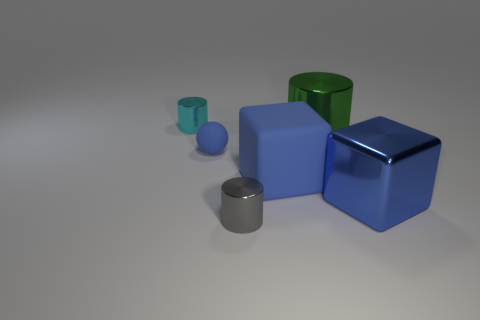There is a cyan object that is the same size as the blue ball; what material is it?
Keep it short and to the point. Metal. The big blue rubber object has what shape?
Ensure brevity in your answer.  Cube. What is the shape of the blue object left of the tiny cylinder in front of the big shiny block?
Ensure brevity in your answer.  Sphere. What material is the big block that is the same color as the big rubber object?
Give a very brief answer. Metal. There is a large thing that is the same material as the large green cylinder; what color is it?
Give a very brief answer. Blue. Are there any other things that are the same size as the sphere?
Your answer should be compact. Yes. There is a rubber thing left of the gray metallic cylinder; is it the same color as the big cube right of the large green metallic cylinder?
Offer a very short reply. Yes. Are there more small things to the right of the cyan cylinder than big blue metallic things that are in front of the shiny block?
Your answer should be compact. Yes. The other small metal object that is the same shape as the small cyan metal thing is what color?
Give a very brief answer. Gray. Is there any other thing that is the same shape as the tiny blue matte object?
Give a very brief answer. No. 